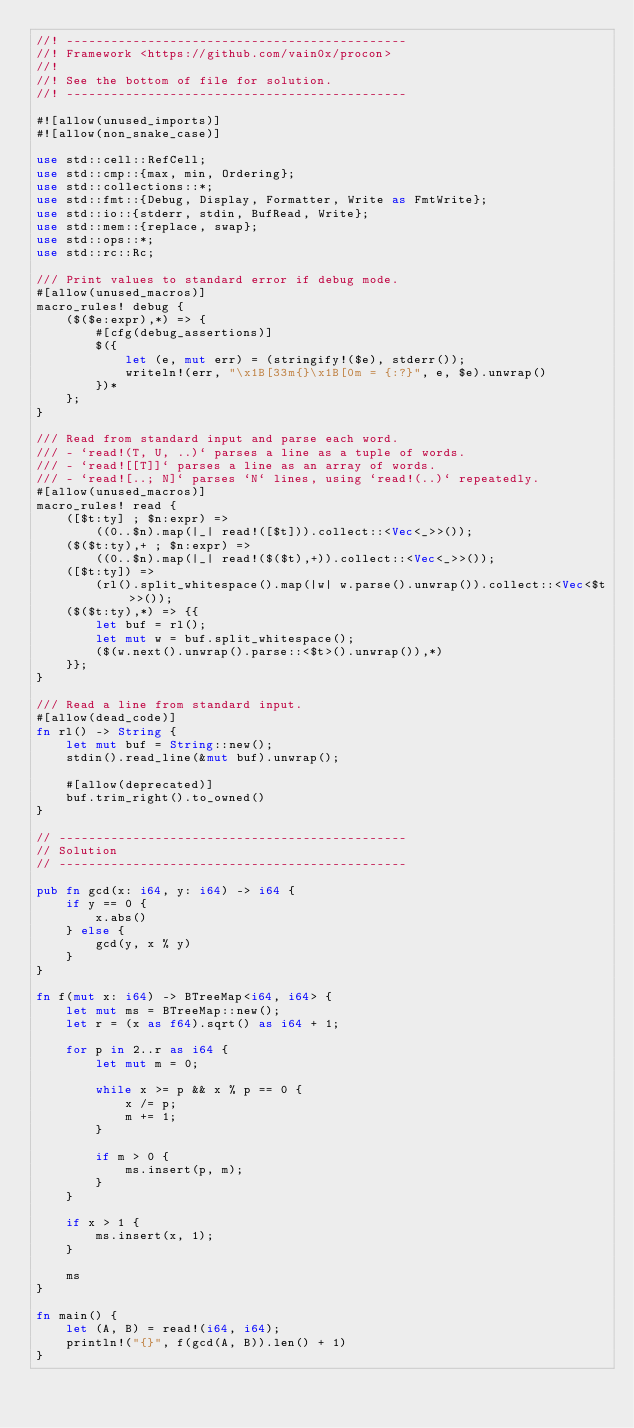<code> <loc_0><loc_0><loc_500><loc_500><_Rust_>//! ----------------------------------------------
//! Framework <https://github.com/vain0x/procon>
//!
//! See the bottom of file for solution.
//! ----------------------------------------------

#![allow(unused_imports)]
#![allow(non_snake_case)]

use std::cell::RefCell;
use std::cmp::{max, min, Ordering};
use std::collections::*;
use std::fmt::{Debug, Display, Formatter, Write as FmtWrite};
use std::io::{stderr, stdin, BufRead, Write};
use std::mem::{replace, swap};
use std::ops::*;
use std::rc::Rc;

/// Print values to standard error if debug mode.
#[allow(unused_macros)]
macro_rules! debug {
    ($($e:expr),*) => {
        #[cfg(debug_assertions)]
        $({
            let (e, mut err) = (stringify!($e), stderr());
            writeln!(err, "\x1B[33m{}\x1B[0m = {:?}", e, $e).unwrap()
        })*
    };
}

/// Read from standard input and parse each word.
/// - `read!(T, U, ..)` parses a line as a tuple of words.
/// - `read![[T]]` parses a line as an array of words.
/// - `read![..; N]` parses `N` lines, using `read!(..)` repeatedly.
#[allow(unused_macros)]
macro_rules! read {
    ([$t:ty] ; $n:expr) =>
        ((0..$n).map(|_| read!([$t])).collect::<Vec<_>>());
    ($($t:ty),+ ; $n:expr) =>
        ((0..$n).map(|_| read!($($t),+)).collect::<Vec<_>>());
    ([$t:ty]) =>
        (rl().split_whitespace().map(|w| w.parse().unwrap()).collect::<Vec<$t>>());
    ($($t:ty),*) => {{
        let buf = rl();
        let mut w = buf.split_whitespace();
        ($(w.next().unwrap().parse::<$t>().unwrap()),*)
    }};
}

/// Read a line from standard input.
#[allow(dead_code)]
fn rl() -> String {
    let mut buf = String::new();
    stdin().read_line(&mut buf).unwrap();

    #[allow(deprecated)]
    buf.trim_right().to_owned()
}

// -----------------------------------------------
// Solution
// -----------------------------------------------

pub fn gcd(x: i64, y: i64) -> i64 {
    if y == 0 {
        x.abs()
    } else {
        gcd(y, x % y)
    }
}

fn f(mut x: i64) -> BTreeMap<i64, i64> {
    let mut ms = BTreeMap::new();
    let r = (x as f64).sqrt() as i64 + 1;

    for p in 2..r as i64 {
        let mut m = 0;

        while x >= p && x % p == 0 {
            x /= p;
            m += 1;
        }

        if m > 0 {
            ms.insert(p, m);
        }
    }

    if x > 1 {
        ms.insert(x, 1);
    }

    ms
}

fn main() {
    let (A, B) = read!(i64, i64);
    println!("{}", f(gcd(A, B)).len() + 1)
}
</code> 